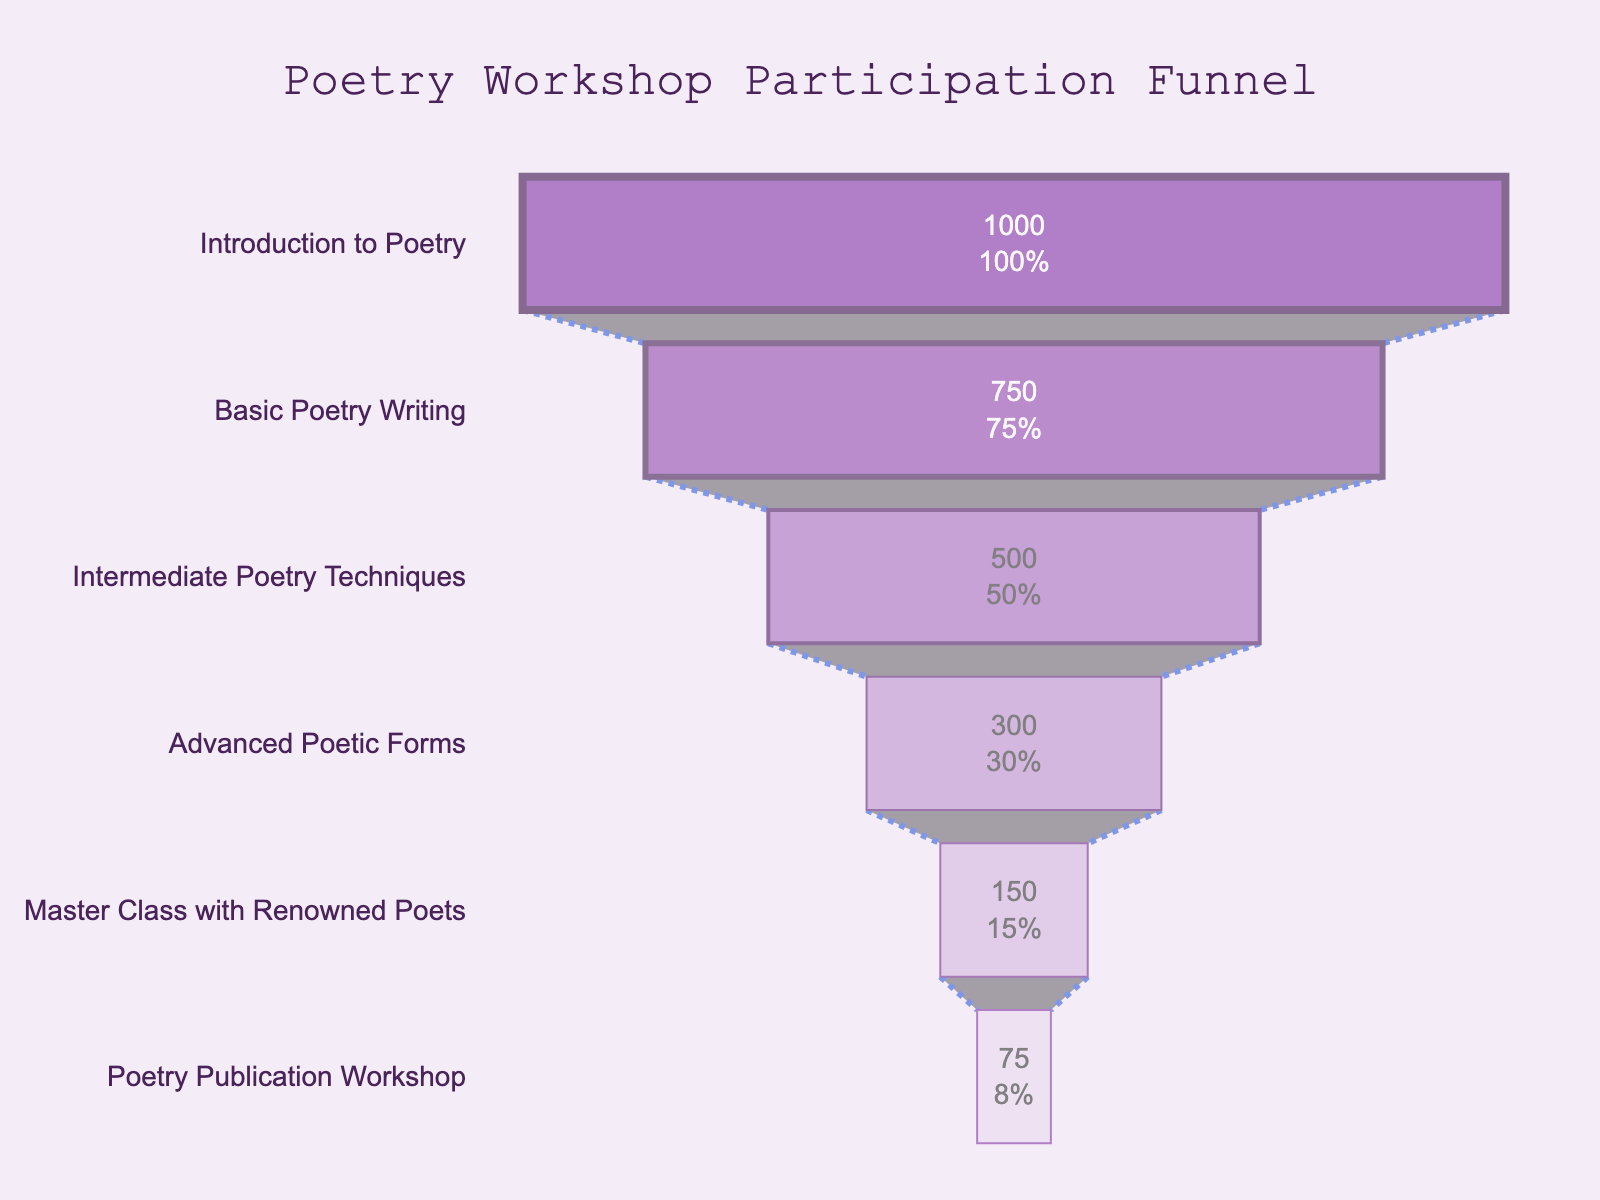What is the title of the funnel chart? The title is usually located at the top of the chart, providing a summary of what the chart represents.
Answer: Poetry Workshop Participation Funnel How many stages are included in the funnel chart? By observing the chart, count the number of distinct stages listed in the vertical axis (y-axis).
Answer: Six Which stage has the highest number of participants? Look for the stage at the widest part of the funnel, which corresponds to the maximum number of participants at the top of the chart.
Answer: Introduction to Poetry How many participants are in the "Master Class with Renowned Poets"? Find the specific stage labeled "Master Class with Renowned Poets" and read the participant number directly from the chart.
Answer: 150 What is the percentage change in participants from the "Intermediate Poetry Techniques" to the "Advanced Poetic Forms" stages? Calculate the percentage change using the formula: ((new number - old number) / old number) * 100. Here, it's ((300 - 500) / 500) * 100.
Answer: -40% What is the total number of participants across all stages? Add up the number of participants from each stage: 1000 + 750 + 500 + 300 + 150 + 75.
Answer: 2775 Which stage sees the most significant drop in participant numbers? Identify the stage transition with the largest decrease in participants by comparing each consecutive stage's participant numbers and finding the maximum difference.
Answer: Basic Poetry Writing to Intermediate Poetry Techniques Arrange the stages in descending order of participation. List the stages starting from the one with the highest number of participants to the one with the lowest by examining the chart.
Answer: Introduction to Poetry, Basic Poetry Writing, Intermediate Poetry Techniques, Advanced Poetic Forms, Master Class with Renowned Poets, Poetry Publication Workshop What is the combined percentage of participants for the "Advanced Poetic Forms" and "Master Class with Renowned Poets" stages relative to the "Introduction to Poetry"? Calculate the sum of participants for these stages (300 + 150), then divide by the number of participants in "Introduction to Poetry" (1000), and multiply by 100: ((300 + 150) / 1000) * 100.
Answer: 45% What is the average number of participants per stage? Sum the participants across all stages (2775), then divide by the number of stages (6): 2775 / 6.
Answer: 462.5 